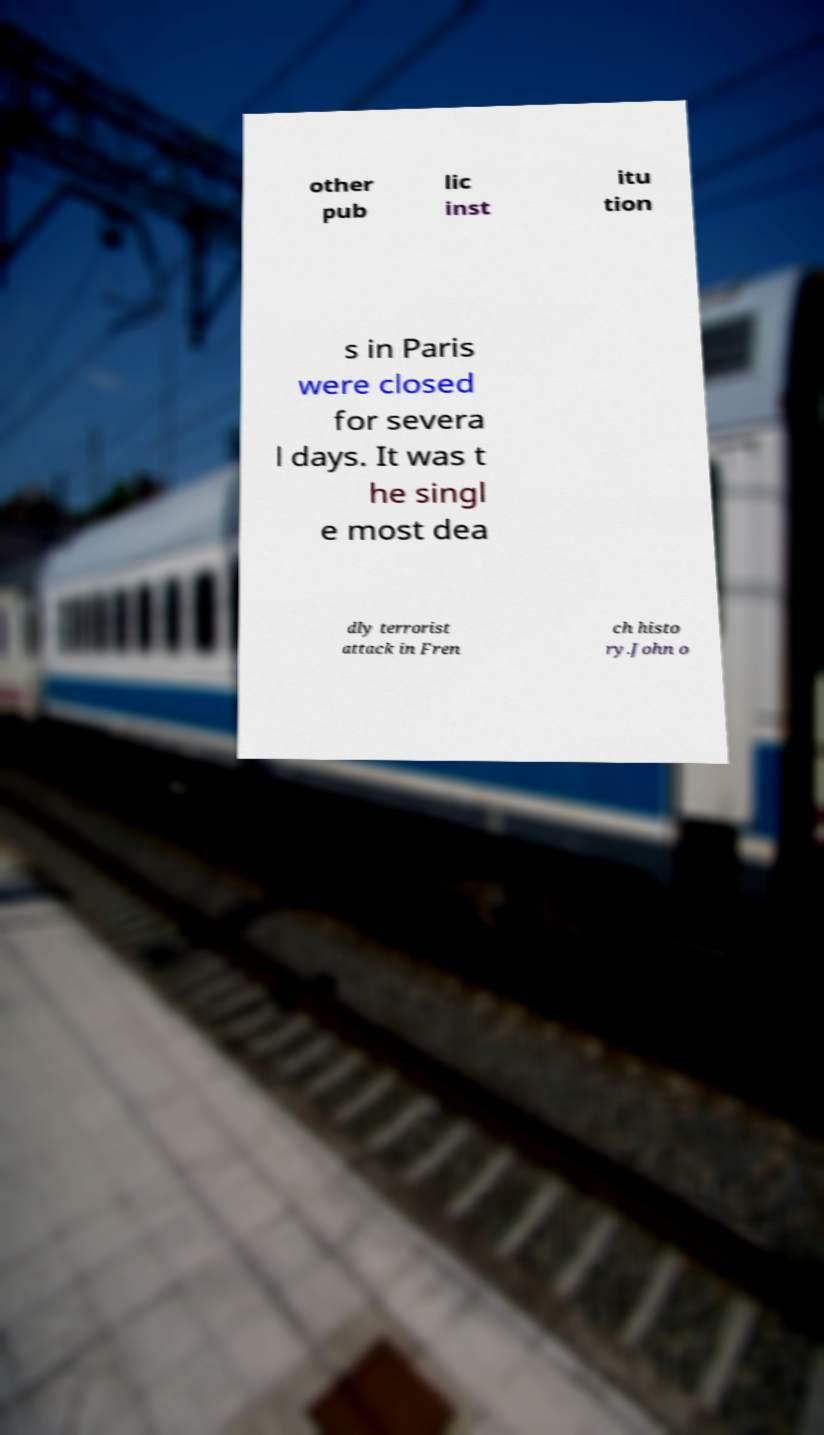Can you accurately transcribe the text from the provided image for me? other pub lic inst itu tion s in Paris were closed for severa l days. It was t he singl e most dea dly terrorist attack in Fren ch histo ry.John o 